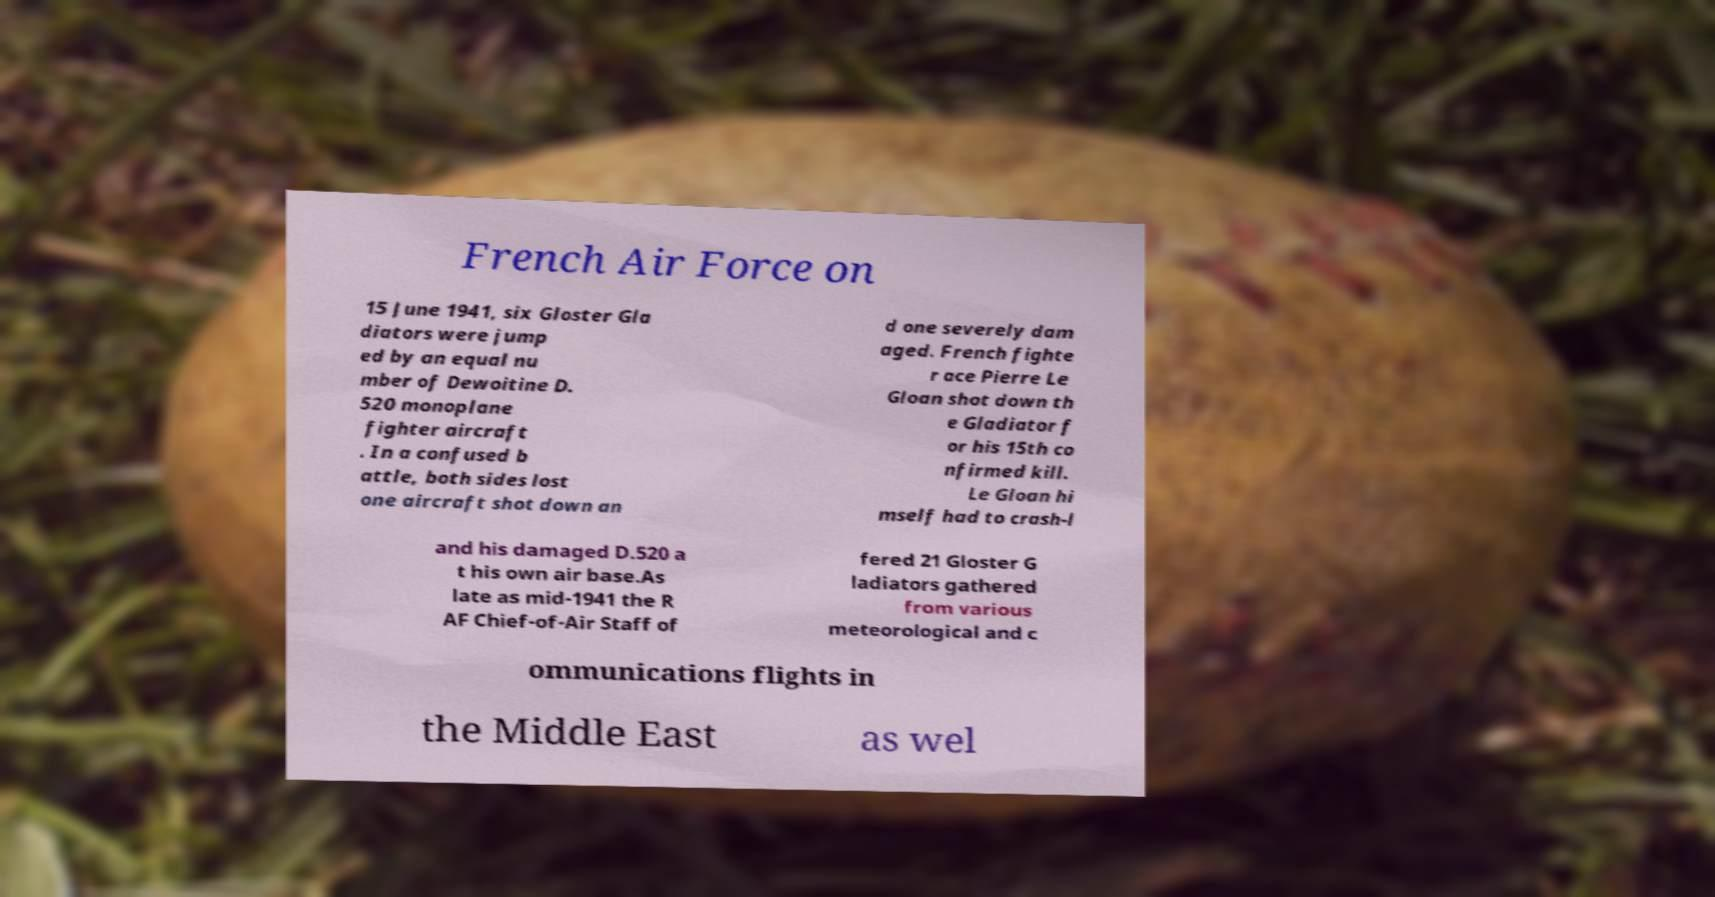Could you extract and type out the text from this image? French Air Force on 15 June 1941, six Gloster Gla diators were jump ed by an equal nu mber of Dewoitine D. 520 monoplane fighter aircraft . In a confused b attle, both sides lost one aircraft shot down an d one severely dam aged. French fighte r ace Pierre Le Gloan shot down th e Gladiator f or his 15th co nfirmed kill. Le Gloan hi mself had to crash-l and his damaged D.520 a t his own air base.As late as mid-1941 the R AF Chief-of-Air Staff of fered 21 Gloster G ladiators gathered from various meteorological and c ommunications flights in the Middle East as wel 